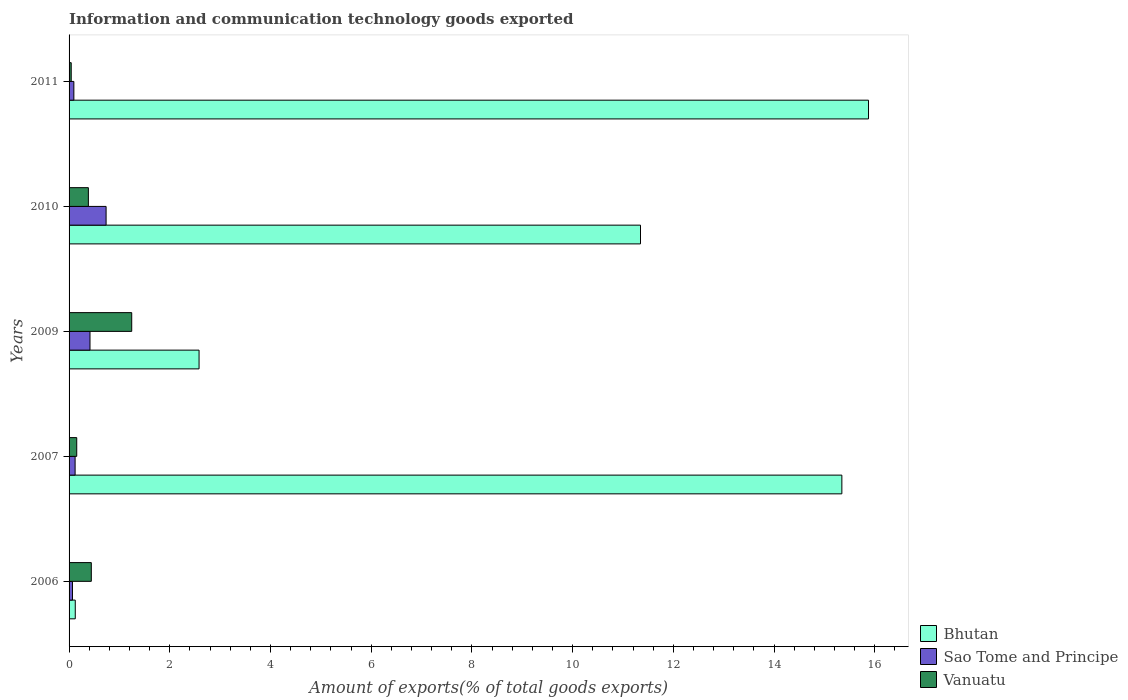How many different coloured bars are there?
Your response must be concise. 3. Are the number of bars per tick equal to the number of legend labels?
Make the answer very short. Yes. How many bars are there on the 2nd tick from the top?
Offer a very short reply. 3. How many bars are there on the 3rd tick from the bottom?
Your answer should be very brief. 3. What is the label of the 1st group of bars from the top?
Your response must be concise. 2011. In how many cases, is the number of bars for a given year not equal to the number of legend labels?
Make the answer very short. 0. What is the amount of goods exported in Sao Tome and Principe in 2011?
Offer a terse response. 0.1. Across all years, what is the maximum amount of goods exported in Vanuatu?
Your answer should be very brief. 1.24. Across all years, what is the minimum amount of goods exported in Bhutan?
Your answer should be very brief. 0.12. In which year was the amount of goods exported in Bhutan maximum?
Keep it short and to the point. 2011. In which year was the amount of goods exported in Bhutan minimum?
Provide a succinct answer. 2006. What is the total amount of goods exported in Bhutan in the graph?
Your answer should be compact. 45.27. What is the difference between the amount of goods exported in Sao Tome and Principe in 2006 and that in 2011?
Keep it short and to the point. -0.03. What is the difference between the amount of goods exported in Vanuatu in 2010 and the amount of goods exported in Bhutan in 2009?
Your response must be concise. -2.2. What is the average amount of goods exported in Bhutan per year?
Keep it short and to the point. 9.05. In the year 2007, what is the difference between the amount of goods exported in Sao Tome and Principe and amount of goods exported in Vanuatu?
Your response must be concise. -0.03. In how many years, is the amount of goods exported in Bhutan greater than 2.4 %?
Provide a short and direct response. 4. What is the ratio of the amount of goods exported in Sao Tome and Principe in 2010 to that in 2011?
Your answer should be very brief. 7.73. Is the amount of goods exported in Sao Tome and Principe in 2009 less than that in 2010?
Your answer should be compact. Yes. Is the difference between the amount of goods exported in Sao Tome and Principe in 2006 and 2009 greater than the difference between the amount of goods exported in Vanuatu in 2006 and 2009?
Provide a succinct answer. Yes. What is the difference between the highest and the second highest amount of goods exported in Bhutan?
Offer a terse response. 0.53. What is the difference between the highest and the lowest amount of goods exported in Vanuatu?
Your answer should be very brief. 1.2. In how many years, is the amount of goods exported in Vanuatu greater than the average amount of goods exported in Vanuatu taken over all years?
Give a very brief answer. 1. What does the 1st bar from the top in 2007 represents?
Offer a very short reply. Vanuatu. What does the 2nd bar from the bottom in 2011 represents?
Provide a short and direct response. Sao Tome and Principe. Is it the case that in every year, the sum of the amount of goods exported in Bhutan and amount of goods exported in Vanuatu is greater than the amount of goods exported in Sao Tome and Principe?
Make the answer very short. Yes. Does the graph contain grids?
Offer a very short reply. No. Where does the legend appear in the graph?
Your answer should be very brief. Bottom right. What is the title of the graph?
Your response must be concise. Information and communication technology goods exported. What is the label or title of the X-axis?
Your answer should be compact. Amount of exports(% of total goods exports). What is the label or title of the Y-axis?
Offer a very short reply. Years. What is the Amount of exports(% of total goods exports) of Bhutan in 2006?
Provide a short and direct response. 0.12. What is the Amount of exports(% of total goods exports) of Sao Tome and Principe in 2006?
Provide a short and direct response. 0.07. What is the Amount of exports(% of total goods exports) of Vanuatu in 2006?
Provide a succinct answer. 0.44. What is the Amount of exports(% of total goods exports) in Bhutan in 2007?
Offer a very short reply. 15.35. What is the Amount of exports(% of total goods exports) of Sao Tome and Principe in 2007?
Your answer should be very brief. 0.12. What is the Amount of exports(% of total goods exports) in Vanuatu in 2007?
Give a very brief answer. 0.15. What is the Amount of exports(% of total goods exports) in Bhutan in 2009?
Your answer should be compact. 2.58. What is the Amount of exports(% of total goods exports) of Sao Tome and Principe in 2009?
Offer a terse response. 0.42. What is the Amount of exports(% of total goods exports) in Vanuatu in 2009?
Offer a very short reply. 1.24. What is the Amount of exports(% of total goods exports) in Bhutan in 2010?
Your answer should be compact. 11.35. What is the Amount of exports(% of total goods exports) in Sao Tome and Principe in 2010?
Offer a very short reply. 0.74. What is the Amount of exports(% of total goods exports) of Vanuatu in 2010?
Your answer should be very brief. 0.38. What is the Amount of exports(% of total goods exports) in Bhutan in 2011?
Your response must be concise. 15.87. What is the Amount of exports(% of total goods exports) of Sao Tome and Principe in 2011?
Your response must be concise. 0.1. What is the Amount of exports(% of total goods exports) in Vanuatu in 2011?
Your answer should be compact. 0.04. Across all years, what is the maximum Amount of exports(% of total goods exports) in Bhutan?
Your answer should be very brief. 15.87. Across all years, what is the maximum Amount of exports(% of total goods exports) in Sao Tome and Principe?
Your response must be concise. 0.74. Across all years, what is the maximum Amount of exports(% of total goods exports) of Vanuatu?
Keep it short and to the point. 1.24. Across all years, what is the minimum Amount of exports(% of total goods exports) of Bhutan?
Offer a terse response. 0.12. Across all years, what is the minimum Amount of exports(% of total goods exports) in Sao Tome and Principe?
Offer a terse response. 0.07. Across all years, what is the minimum Amount of exports(% of total goods exports) in Vanuatu?
Your response must be concise. 0.04. What is the total Amount of exports(% of total goods exports) of Bhutan in the graph?
Make the answer very short. 45.27. What is the total Amount of exports(% of total goods exports) in Sao Tome and Principe in the graph?
Offer a terse response. 1.43. What is the total Amount of exports(% of total goods exports) in Vanuatu in the graph?
Your answer should be compact. 2.26. What is the difference between the Amount of exports(% of total goods exports) of Bhutan in 2006 and that in 2007?
Offer a very short reply. -15.22. What is the difference between the Amount of exports(% of total goods exports) of Sao Tome and Principe in 2006 and that in 2007?
Give a very brief answer. -0.05. What is the difference between the Amount of exports(% of total goods exports) in Vanuatu in 2006 and that in 2007?
Make the answer very short. 0.29. What is the difference between the Amount of exports(% of total goods exports) of Bhutan in 2006 and that in 2009?
Your answer should be very brief. -2.46. What is the difference between the Amount of exports(% of total goods exports) in Sao Tome and Principe in 2006 and that in 2009?
Your response must be concise. -0.35. What is the difference between the Amount of exports(% of total goods exports) of Vanuatu in 2006 and that in 2009?
Your answer should be very brief. -0.8. What is the difference between the Amount of exports(% of total goods exports) of Bhutan in 2006 and that in 2010?
Your answer should be compact. -11.22. What is the difference between the Amount of exports(% of total goods exports) in Sao Tome and Principe in 2006 and that in 2010?
Make the answer very short. -0.67. What is the difference between the Amount of exports(% of total goods exports) in Vanuatu in 2006 and that in 2010?
Provide a succinct answer. 0.06. What is the difference between the Amount of exports(% of total goods exports) of Bhutan in 2006 and that in 2011?
Keep it short and to the point. -15.75. What is the difference between the Amount of exports(% of total goods exports) of Sao Tome and Principe in 2006 and that in 2011?
Offer a very short reply. -0.03. What is the difference between the Amount of exports(% of total goods exports) of Vanuatu in 2006 and that in 2011?
Provide a short and direct response. 0.4. What is the difference between the Amount of exports(% of total goods exports) in Bhutan in 2007 and that in 2009?
Your answer should be very brief. 12.76. What is the difference between the Amount of exports(% of total goods exports) of Sao Tome and Principe in 2007 and that in 2009?
Offer a terse response. -0.3. What is the difference between the Amount of exports(% of total goods exports) of Vanuatu in 2007 and that in 2009?
Provide a short and direct response. -1.09. What is the difference between the Amount of exports(% of total goods exports) of Bhutan in 2007 and that in 2010?
Keep it short and to the point. 4. What is the difference between the Amount of exports(% of total goods exports) in Sao Tome and Principe in 2007 and that in 2010?
Ensure brevity in your answer.  -0.62. What is the difference between the Amount of exports(% of total goods exports) of Vanuatu in 2007 and that in 2010?
Your response must be concise. -0.23. What is the difference between the Amount of exports(% of total goods exports) in Bhutan in 2007 and that in 2011?
Offer a very short reply. -0.53. What is the difference between the Amount of exports(% of total goods exports) in Sao Tome and Principe in 2007 and that in 2011?
Offer a very short reply. 0.02. What is the difference between the Amount of exports(% of total goods exports) in Vanuatu in 2007 and that in 2011?
Your answer should be very brief. 0.11. What is the difference between the Amount of exports(% of total goods exports) in Bhutan in 2009 and that in 2010?
Give a very brief answer. -8.77. What is the difference between the Amount of exports(% of total goods exports) of Sao Tome and Principe in 2009 and that in 2010?
Give a very brief answer. -0.32. What is the difference between the Amount of exports(% of total goods exports) in Vanuatu in 2009 and that in 2010?
Keep it short and to the point. 0.86. What is the difference between the Amount of exports(% of total goods exports) of Bhutan in 2009 and that in 2011?
Offer a very short reply. -13.29. What is the difference between the Amount of exports(% of total goods exports) of Sao Tome and Principe in 2009 and that in 2011?
Your answer should be compact. 0.32. What is the difference between the Amount of exports(% of total goods exports) in Vanuatu in 2009 and that in 2011?
Provide a short and direct response. 1.2. What is the difference between the Amount of exports(% of total goods exports) of Bhutan in 2010 and that in 2011?
Provide a short and direct response. -4.53. What is the difference between the Amount of exports(% of total goods exports) in Sao Tome and Principe in 2010 and that in 2011?
Give a very brief answer. 0.64. What is the difference between the Amount of exports(% of total goods exports) in Vanuatu in 2010 and that in 2011?
Keep it short and to the point. 0.34. What is the difference between the Amount of exports(% of total goods exports) in Bhutan in 2006 and the Amount of exports(% of total goods exports) in Sao Tome and Principe in 2007?
Offer a very short reply. 0. What is the difference between the Amount of exports(% of total goods exports) in Bhutan in 2006 and the Amount of exports(% of total goods exports) in Vanuatu in 2007?
Provide a succinct answer. -0.03. What is the difference between the Amount of exports(% of total goods exports) in Sao Tome and Principe in 2006 and the Amount of exports(% of total goods exports) in Vanuatu in 2007?
Your answer should be compact. -0.08. What is the difference between the Amount of exports(% of total goods exports) in Bhutan in 2006 and the Amount of exports(% of total goods exports) in Sao Tome and Principe in 2009?
Provide a succinct answer. -0.29. What is the difference between the Amount of exports(% of total goods exports) of Bhutan in 2006 and the Amount of exports(% of total goods exports) of Vanuatu in 2009?
Your answer should be very brief. -1.12. What is the difference between the Amount of exports(% of total goods exports) in Sao Tome and Principe in 2006 and the Amount of exports(% of total goods exports) in Vanuatu in 2009?
Keep it short and to the point. -1.18. What is the difference between the Amount of exports(% of total goods exports) in Bhutan in 2006 and the Amount of exports(% of total goods exports) in Sao Tome and Principe in 2010?
Keep it short and to the point. -0.61. What is the difference between the Amount of exports(% of total goods exports) of Bhutan in 2006 and the Amount of exports(% of total goods exports) of Vanuatu in 2010?
Give a very brief answer. -0.26. What is the difference between the Amount of exports(% of total goods exports) in Sao Tome and Principe in 2006 and the Amount of exports(% of total goods exports) in Vanuatu in 2010?
Your answer should be compact. -0.32. What is the difference between the Amount of exports(% of total goods exports) of Bhutan in 2006 and the Amount of exports(% of total goods exports) of Sao Tome and Principe in 2011?
Provide a short and direct response. 0.03. What is the difference between the Amount of exports(% of total goods exports) of Bhutan in 2006 and the Amount of exports(% of total goods exports) of Vanuatu in 2011?
Offer a very short reply. 0.08. What is the difference between the Amount of exports(% of total goods exports) in Sao Tome and Principe in 2006 and the Amount of exports(% of total goods exports) in Vanuatu in 2011?
Ensure brevity in your answer.  0.02. What is the difference between the Amount of exports(% of total goods exports) of Bhutan in 2007 and the Amount of exports(% of total goods exports) of Sao Tome and Principe in 2009?
Offer a very short reply. 14.93. What is the difference between the Amount of exports(% of total goods exports) of Bhutan in 2007 and the Amount of exports(% of total goods exports) of Vanuatu in 2009?
Your answer should be very brief. 14.1. What is the difference between the Amount of exports(% of total goods exports) in Sao Tome and Principe in 2007 and the Amount of exports(% of total goods exports) in Vanuatu in 2009?
Make the answer very short. -1.12. What is the difference between the Amount of exports(% of total goods exports) of Bhutan in 2007 and the Amount of exports(% of total goods exports) of Sao Tome and Principe in 2010?
Give a very brief answer. 14.61. What is the difference between the Amount of exports(% of total goods exports) of Bhutan in 2007 and the Amount of exports(% of total goods exports) of Vanuatu in 2010?
Provide a short and direct response. 14.96. What is the difference between the Amount of exports(% of total goods exports) in Sao Tome and Principe in 2007 and the Amount of exports(% of total goods exports) in Vanuatu in 2010?
Make the answer very short. -0.26. What is the difference between the Amount of exports(% of total goods exports) in Bhutan in 2007 and the Amount of exports(% of total goods exports) in Sao Tome and Principe in 2011?
Make the answer very short. 15.25. What is the difference between the Amount of exports(% of total goods exports) of Bhutan in 2007 and the Amount of exports(% of total goods exports) of Vanuatu in 2011?
Ensure brevity in your answer.  15.3. What is the difference between the Amount of exports(% of total goods exports) in Sao Tome and Principe in 2007 and the Amount of exports(% of total goods exports) in Vanuatu in 2011?
Provide a short and direct response. 0.08. What is the difference between the Amount of exports(% of total goods exports) in Bhutan in 2009 and the Amount of exports(% of total goods exports) in Sao Tome and Principe in 2010?
Ensure brevity in your answer.  1.85. What is the difference between the Amount of exports(% of total goods exports) in Bhutan in 2009 and the Amount of exports(% of total goods exports) in Vanuatu in 2010?
Make the answer very short. 2.2. What is the difference between the Amount of exports(% of total goods exports) of Sao Tome and Principe in 2009 and the Amount of exports(% of total goods exports) of Vanuatu in 2010?
Your response must be concise. 0.03. What is the difference between the Amount of exports(% of total goods exports) of Bhutan in 2009 and the Amount of exports(% of total goods exports) of Sao Tome and Principe in 2011?
Your response must be concise. 2.49. What is the difference between the Amount of exports(% of total goods exports) in Bhutan in 2009 and the Amount of exports(% of total goods exports) in Vanuatu in 2011?
Offer a terse response. 2.54. What is the difference between the Amount of exports(% of total goods exports) of Sao Tome and Principe in 2009 and the Amount of exports(% of total goods exports) of Vanuatu in 2011?
Your answer should be very brief. 0.37. What is the difference between the Amount of exports(% of total goods exports) of Bhutan in 2010 and the Amount of exports(% of total goods exports) of Sao Tome and Principe in 2011?
Keep it short and to the point. 11.25. What is the difference between the Amount of exports(% of total goods exports) of Bhutan in 2010 and the Amount of exports(% of total goods exports) of Vanuatu in 2011?
Offer a terse response. 11.3. What is the difference between the Amount of exports(% of total goods exports) in Sao Tome and Principe in 2010 and the Amount of exports(% of total goods exports) in Vanuatu in 2011?
Give a very brief answer. 0.69. What is the average Amount of exports(% of total goods exports) of Bhutan per year?
Ensure brevity in your answer.  9.05. What is the average Amount of exports(% of total goods exports) of Sao Tome and Principe per year?
Provide a short and direct response. 0.29. What is the average Amount of exports(% of total goods exports) of Vanuatu per year?
Your response must be concise. 0.45. In the year 2006, what is the difference between the Amount of exports(% of total goods exports) of Bhutan and Amount of exports(% of total goods exports) of Sao Tome and Principe?
Provide a succinct answer. 0.06. In the year 2006, what is the difference between the Amount of exports(% of total goods exports) in Bhutan and Amount of exports(% of total goods exports) in Vanuatu?
Provide a succinct answer. -0.32. In the year 2006, what is the difference between the Amount of exports(% of total goods exports) in Sao Tome and Principe and Amount of exports(% of total goods exports) in Vanuatu?
Your answer should be very brief. -0.37. In the year 2007, what is the difference between the Amount of exports(% of total goods exports) in Bhutan and Amount of exports(% of total goods exports) in Sao Tome and Principe?
Your response must be concise. 15.23. In the year 2007, what is the difference between the Amount of exports(% of total goods exports) in Bhutan and Amount of exports(% of total goods exports) in Vanuatu?
Your response must be concise. 15.19. In the year 2007, what is the difference between the Amount of exports(% of total goods exports) of Sao Tome and Principe and Amount of exports(% of total goods exports) of Vanuatu?
Keep it short and to the point. -0.03. In the year 2009, what is the difference between the Amount of exports(% of total goods exports) of Bhutan and Amount of exports(% of total goods exports) of Sao Tome and Principe?
Provide a short and direct response. 2.17. In the year 2009, what is the difference between the Amount of exports(% of total goods exports) of Bhutan and Amount of exports(% of total goods exports) of Vanuatu?
Provide a succinct answer. 1.34. In the year 2009, what is the difference between the Amount of exports(% of total goods exports) of Sao Tome and Principe and Amount of exports(% of total goods exports) of Vanuatu?
Make the answer very short. -0.83. In the year 2010, what is the difference between the Amount of exports(% of total goods exports) of Bhutan and Amount of exports(% of total goods exports) of Sao Tome and Principe?
Make the answer very short. 10.61. In the year 2010, what is the difference between the Amount of exports(% of total goods exports) of Bhutan and Amount of exports(% of total goods exports) of Vanuatu?
Give a very brief answer. 10.96. In the year 2010, what is the difference between the Amount of exports(% of total goods exports) of Sao Tome and Principe and Amount of exports(% of total goods exports) of Vanuatu?
Your response must be concise. 0.35. In the year 2011, what is the difference between the Amount of exports(% of total goods exports) in Bhutan and Amount of exports(% of total goods exports) in Sao Tome and Principe?
Your answer should be compact. 15.78. In the year 2011, what is the difference between the Amount of exports(% of total goods exports) of Bhutan and Amount of exports(% of total goods exports) of Vanuatu?
Your answer should be very brief. 15.83. In the year 2011, what is the difference between the Amount of exports(% of total goods exports) in Sao Tome and Principe and Amount of exports(% of total goods exports) in Vanuatu?
Offer a terse response. 0.05. What is the ratio of the Amount of exports(% of total goods exports) in Bhutan in 2006 to that in 2007?
Your response must be concise. 0.01. What is the ratio of the Amount of exports(% of total goods exports) of Sao Tome and Principe in 2006 to that in 2007?
Make the answer very short. 0.56. What is the ratio of the Amount of exports(% of total goods exports) of Vanuatu in 2006 to that in 2007?
Ensure brevity in your answer.  2.91. What is the ratio of the Amount of exports(% of total goods exports) of Bhutan in 2006 to that in 2009?
Provide a short and direct response. 0.05. What is the ratio of the Amount of exports(% of total goods exports) in Sao Tome and Principe in 2006 to that in 2009?
Give a very brief answer. 0.16. What is the ratio of the Amount of exports(% of total goods exports) of Vanuatu in 2006 to that in 2009?
Your response must be concise. 0.36. What is the ratio of the Amount of exports(% of total goods exports) in Bhutan in 2006 to that in 2010?
Provide a succinct answer. 0.01. What is the ratio of the Amount of exports(% of total goods exports) of Sao Tome and Principe in 2006 to that in 2010?
Your answer should be compact. 0.09. What is the ratio of the Amount of exports(% of total goods exports) in Vanuatu in 2006 to that in 2010?
Keep it short and to the point. 1.15. What is the ratio of the Amount of exports(% of total goods exports) in Bhutan in 2006 to that in 2011?
Give a very brief answer. 0.01. What is the ratio of the Amount of exports(% of total goods exports) of Sao Tome and Principe in 2006 to that in 2011?
Provide a succinct answer. 0.71. What is the ratio of the Amount of exports(% of total goods exports) of Vanuatu in 2006 to that in 2011?
Give a very brief answer. 10.34. What is the ratio of the Amount of exports(% of total goods exports) in Bhutan in 2007 to that in 2009?
Provide a short and direct response. 5.95. What is the ratio of the Amount of exports(% of total goods exports) in Sao Tome and Principe in 2007 to that in 2009?
Offer a very short reply. 0.29. What is the ratio of the Amount of exports(% of total goods exports) in Vanuatu in 2007 to that in 2009?
Provide a short and direct response. 0.12. What is the ratio of the Amount of exports(% of total goods exports) in Bhutan in 2007 to that in 2010?
Give a very brief answer. 1.35. What is the ratio of the Amount of exports(% of total goods exports) in Sao Tome and Principe in 2007 to that in 2010?
Provide a succinct answer. 0.16. What is the ratio of the Amount of exports(% of total goods exports) of Vanuatu in 2007 to that in 2010?
Offer a terse response. 0.4. What is the ratio of the Amount of exports(% of total goods exports) in Bhutan in 2007 to that in 2011?
Keep it short and to the point. 0.97. What is the ratio of the Amount of exports(% of total goods exports) in Sao Tome and Principe in 2007 to that in 2011?
Keep it short and to the point. 1.26. What is the ratio of the Amount of exports(% of total goods exports) in Vanuatu in 2007 to that in 2011?
Provide a short and direct response. 3.56. What is the ratio of the Amount of exports(% of total goods exports) in Bhutan in 2009 to that in 2010?
Your answer should be very brief. 0.23. What is the ratio of the Amount of exports(% of total goods exports) of Sao Tome and Principe in 2009 to that in 2010?
Provide a succinct answer. 0.57. What is the ratio of the Amount of exports(% of total goods exports) of Vanuatu in 2009 to that in 2010?
Make the answer very short. 3.24. What is the ratio of the Amount of exports(% of total goods exports) of Bhutan in 2009 to that in 2011?
Your response must be concise. 0.16. What is the ratio of the Amount of exports(% of total goods exports) of Sao Tome and Principe in 2009 to that in 2011?
Offer a very short reply. 4.37. What is the ratio of the Amount of exports(% of total goods exports) of Vanuatu in 2009 to that in 2011?
Your response must be concise. 29.11. What is the ratio of the Amount of exports(% of total goods exports) of Bhutan in 2010 to that in 2011?
Provide a succinct answer. 0.71. What is the ratio of the Amount of exports(% of total goods exports) in Sao Tome and Principe in 2010 to that in 2011?
Your response must be concise. 7.73. What is the ratio of the Amount of exports(% of total goods exports) in Vanuatu in 2010 to that in 2011?
Ensure brevity in your answer.  8.97. What is the difference between the highest and the second highest Amount of exports(% of total goods exports) in Bhutan?
Ensure brevity in your answer.  0.53. What is the difference between the highest and the second highest Amount of exports(% of total goods exports) of Sao Tome and Principe?
Provide a succinct answer. 0.32. What is the difference between the highest and the second highest Amount of exports(% of total goods exports) in Vanuatu?
Keep it short and to the point. 0.8. What is the difference between the highest and the lowest Amount of exports(% of total goods exports) in Bhutan?
Give a very brief answer. 15.75. What is the difference between the highest and the lowest Amount of exports(% of total goods exports) in Sao Tome and Principe?
Offer a very short reply. 0.67. What is the difference between the highest and the lowest Amount of exports(% of total goods exports) in Vanuatu?
Provide a short and direct response. 1.2. 